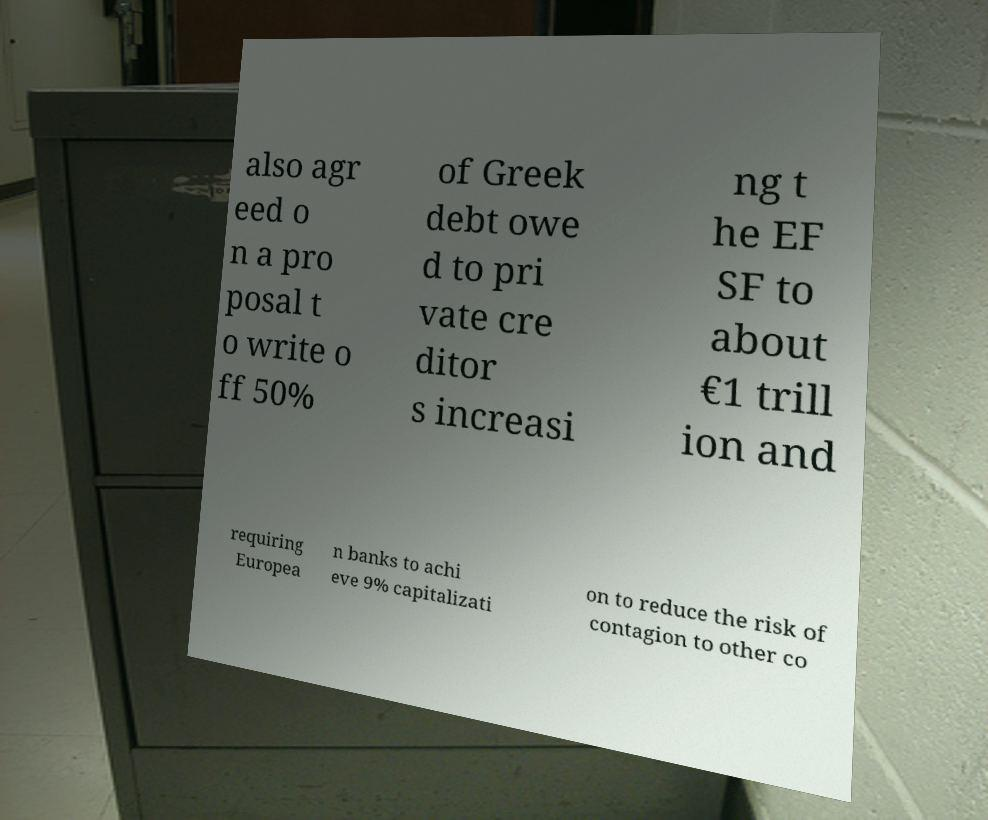I need the written content from this picture converted into text. Can you do that? also agr eed o n a pro posal t o write o ff 50% of Greek debt owe d to pri vate cre ditor s increasi ng t he EF SF to about €1 trill ion and requiring Europea n banks to achi eve 9% capitalizati on to reduce the risk of contagion to other co 